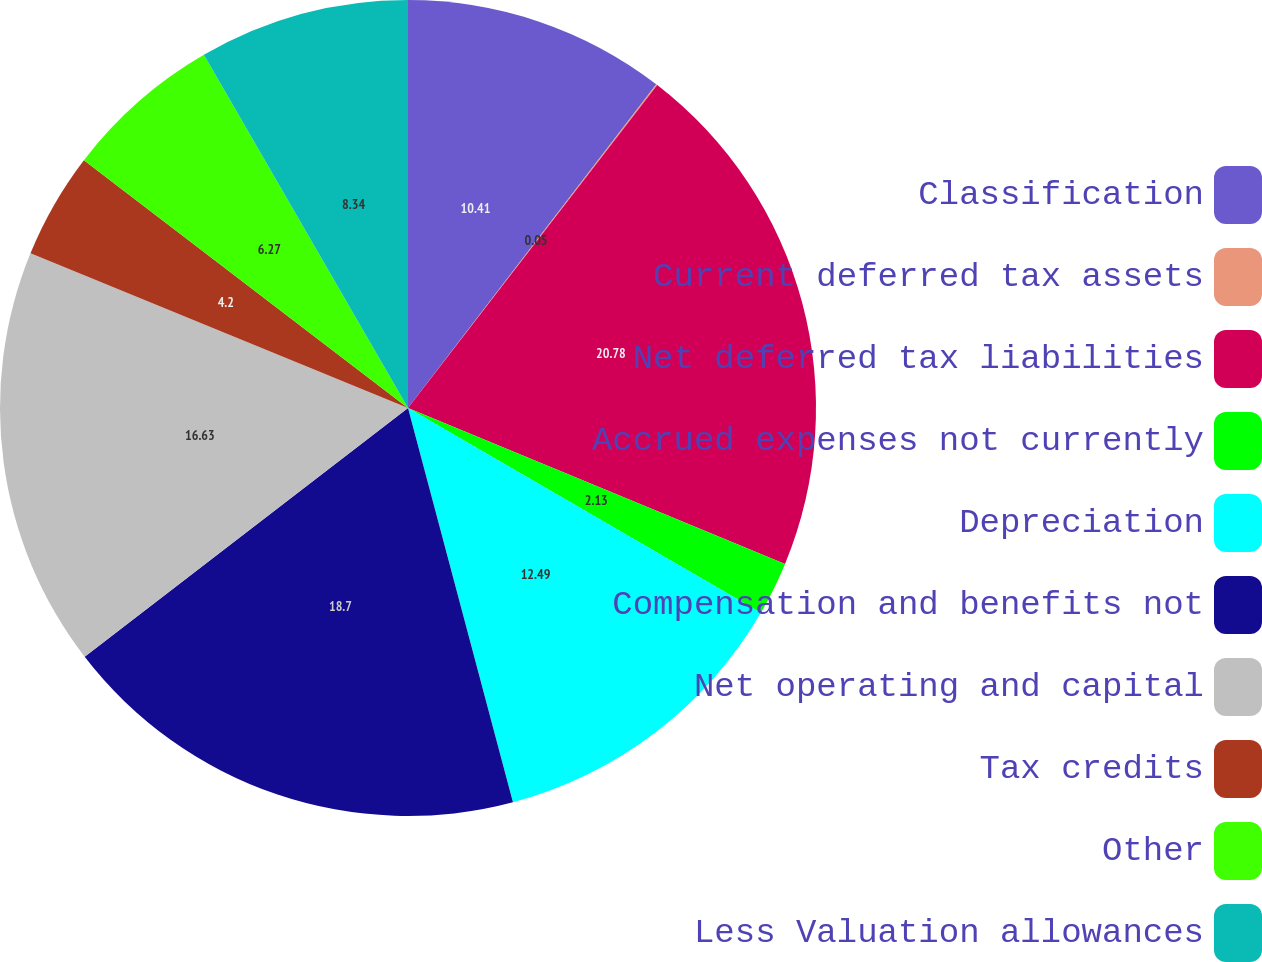<chart> <loc_0><loc_0><loc_500><loc_500><pie_chart><fcel>Classification<fcel>Current deferred tax assets<fcel>Net deferred tax liabilities<fcel>Accrued expenses not currently<fcel>Depreciation<fcel>Compensation and benefits not<fcel>Net operating and capital<fcel>Tax credits<fcel>Other<fcel>Less Valuation allowances<nl><fcel>10.41%<fcel>0.05%<fcel>20.78%<fcel>2.13%<fcel>12.49%<fcel>18.7%<fcel>16.63%<fcel>4.2%<fcel>6.27%<fcel>8.34%<nl></chart> 